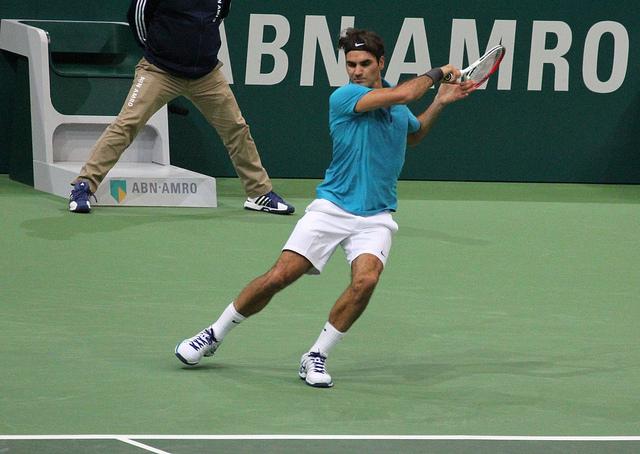What color is the trim on his shoes?
Write a very short answer. Blue. Who is this professional tennis player?
Keep it brief. Yes. Is the player about to perform a backhand?
Quick response, please. No. Who is the sponsor?
Give a very brief answer. Abn amro. What color is the man's shirt?
Short answer required. Blue. 